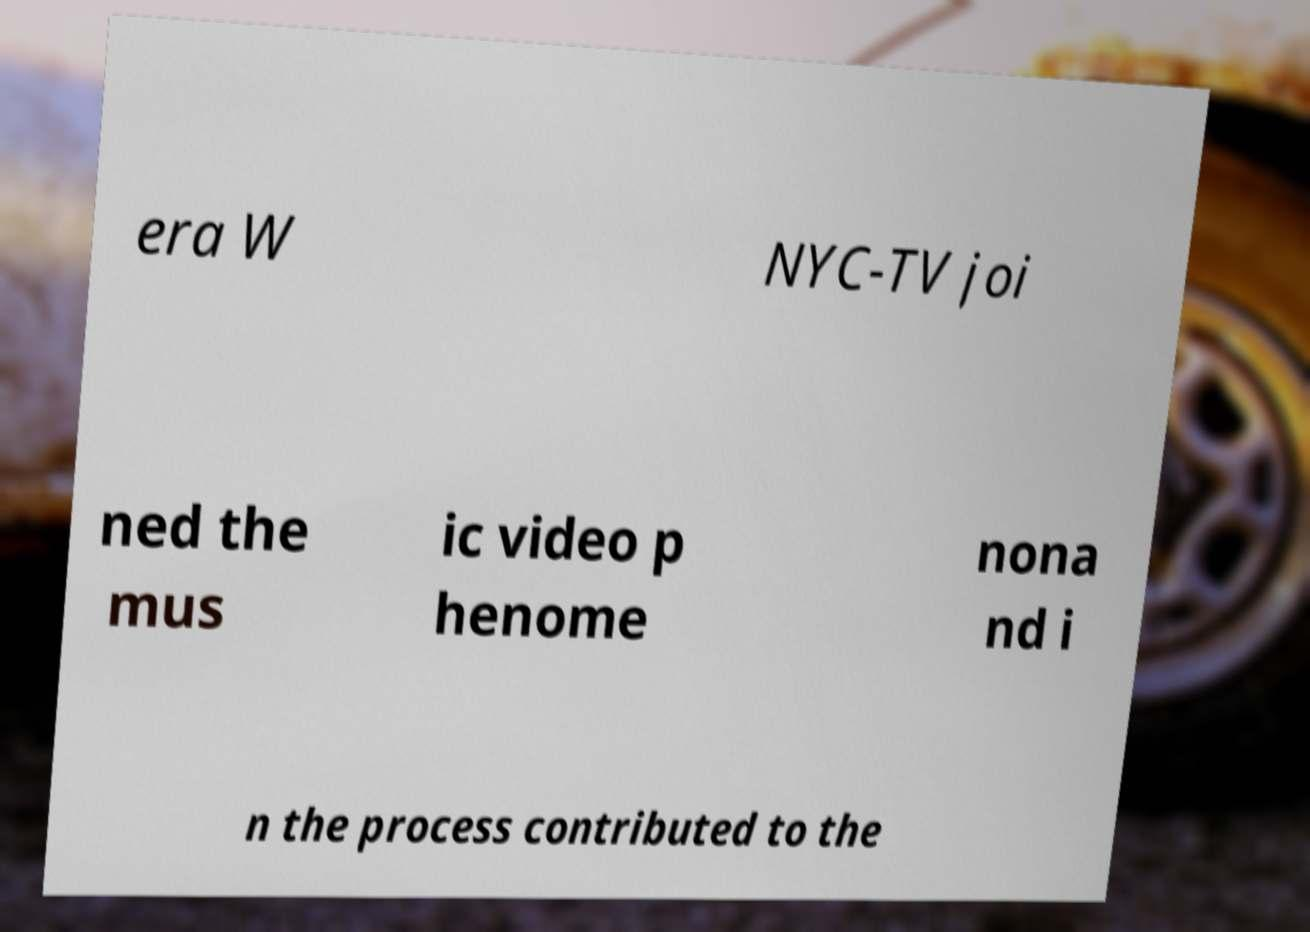I need the written content from this picture converted into text. Can you do that? era W NYC-TV joi ned the mus ic video p henome nona nd i n the process contributed to the 